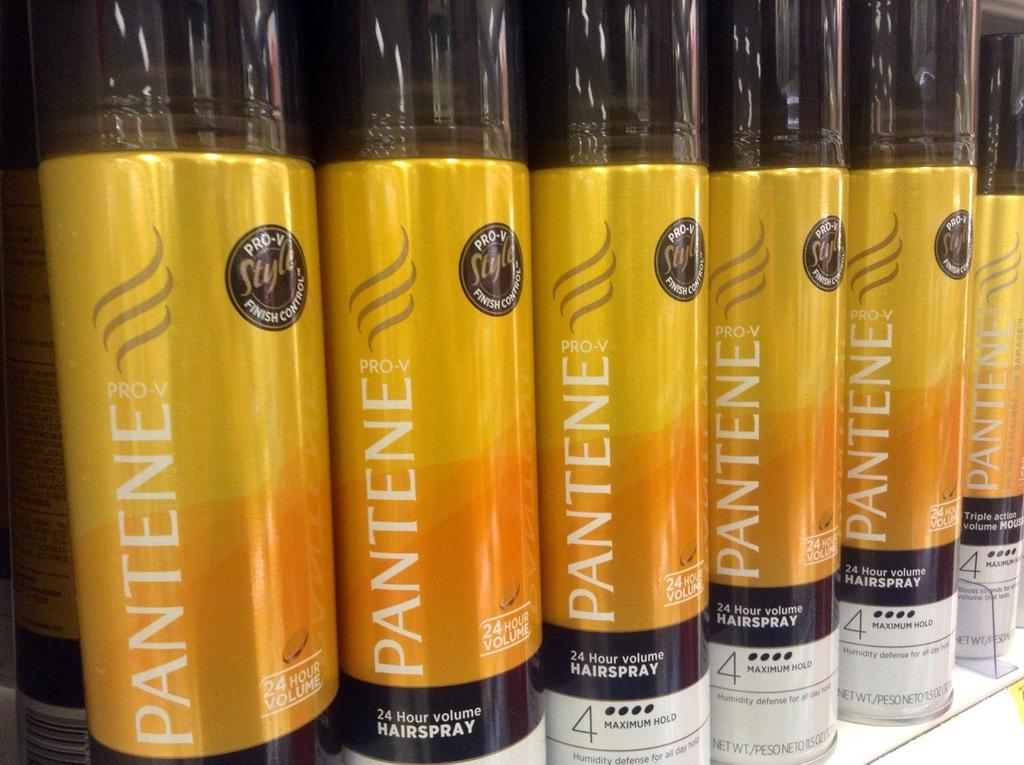<image>
Describe the image concisely. Several yellow and black cans of Pantene pro-v hairspray 